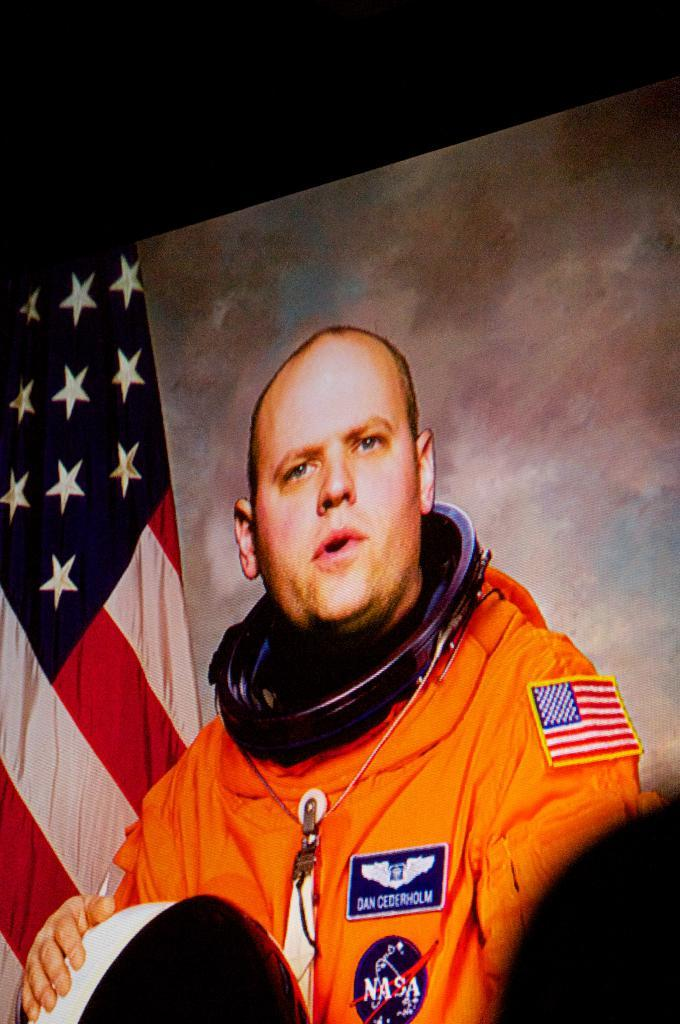What can be seen in the image? There is a person in the image. What is the person doing in the image? The person is holding an object. What is the color of the background behind the person? The background of the person is white. What is the object on the left side of the image? There is a flag truncated towards the left of the image. How many times has the person been rewarded for folding stems in the image? There is no indication of folding stems or rewards in the image. 